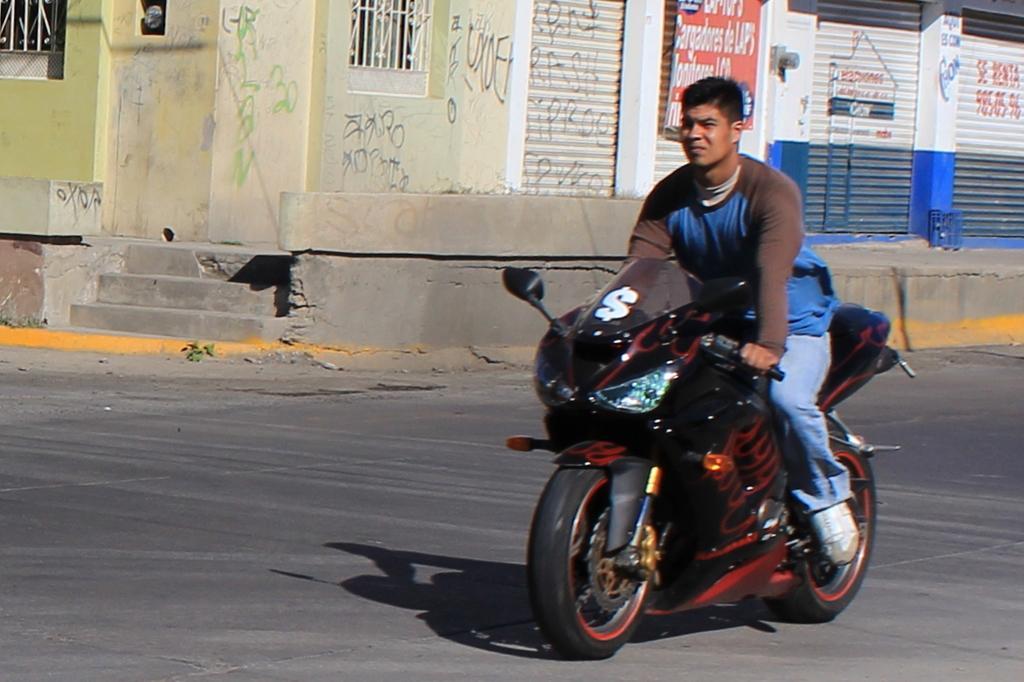In one or two sentences, can you explain what this image depicts? The image is taken outside of the city. In the image there is a man riding a bike, in background there is a buildings and hoarding and we can also see a window which is closed, at bottom there is a road which is in black color. 